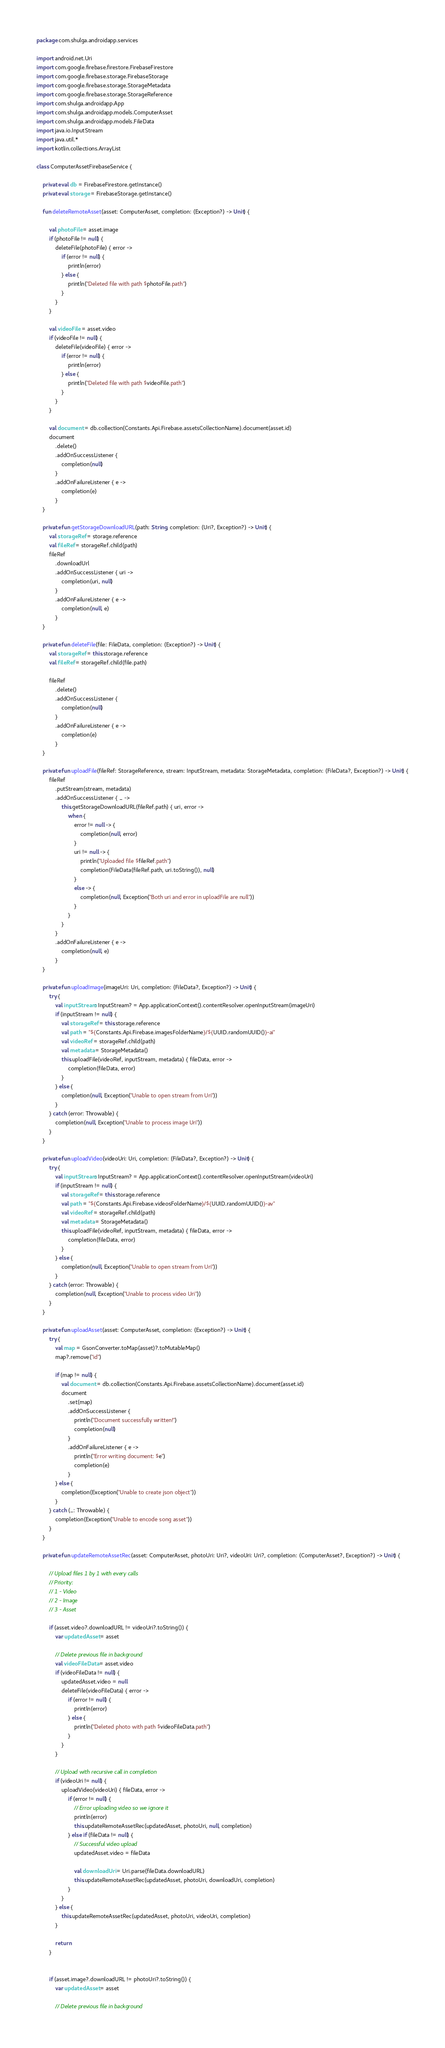Convert code to text. <code><loc_0><loc_0><loc_500><loc_500><_Kotlin_>package com.shulga.androidapp.services

import android.net.Uri
import com.google.firebase.firestore.FirebaseFirestore
import com.google.firebase.storage.FirebaseStorage
import com.google.firebase.storage.StorageMetadata
import com.google.firebase.storage.StorageReference
import com.shulga.androidapp.App
import com.shulga.androidapp.models.ComputerAsset
import com.shulga.androidapp.models.FileData
import java.io.InputStream
import java.util.*
import kotlin.collections.ArrayList

class ComputerAssetFirebaseService {

    private val db = FirebaseFirestore.getInstance()
    private val storage = FirebaseStorage.getInstance()

    fun deleteRemoteAsset(asset: ComputerAsset, completion: (Exception?) -> Unit) {

        val photoFile = asset.image
        if (photoFile != null) {
            deleteFile(photoFile) { error ->
                if (error != null) {
                    println(error)
                } else {
                    println("Deleted file with path $photoFile.path")
                }
            }
        }

        val videoFile = asset.video
        if (videoFile != null) {
            deleteFile(videoFile) { error ->
                if (error != null) {
                    println(error)
                } else {
                    println("Deleted file with path $videoFile.path")
                }
            }
        }

        val document = db.collection(Constants.Api.Firebase.assetsCollectionName).document(asset.id)
        document
            .delete()
            .addOnSuccessListener {
                completion(null)
            }
            .addOnFailureListener { e ->
                completion(e)
            }
    }

    private fun getStorageDownloadURL(path: String, completion: (Uri?, Exception?) -> Unit) {
        val storageRef = storage.reference
        val fileRef = storageRef.child(path)
        fileRef
            .downloadUrl
            .addOnSuccessListener { uri ->
                completion(uri, null)
            }
            .addOnFailureListener { e ->
                completion(null, e)
            }
    }

    private fun deleteFile(file: FileData, completion: (Exception?) -> Unit) {
        val storageRef = this.storage.reference
        val fileRef = storageRef.child(file.path)

        fileRef
            .delete()
            .addOnSuccessListener {
                completion(null)
            }
            .addOnFailureListener { e ->
                completion(e)
            }
    }

    private fun uploadFile(fileRef: StorageReference, stream: InputStream, metadata: StorageMetadata, completion: (FileData?, Exception?) -> Unit) {
        fileRef
            .putStream(stream, metadata)
            .addOnSuccessListener { _ ->
                this.getStorageDownloadURL(fileRef.path) { uri, error ->
                    when {
                        error != null -> {
                            completion(null, error)
                        }
                        uri != null -> {
                            println("Uploaded file $fileRef.path")
                            completion(FileData(fileRef.path, uri.toString()), null)
                        }
                        else -> {
                            completion(null, Exception("Both uri and error in uploadFile are null"))
                        }
                    }
                }
            }
            .addOnFailureListener { e ->
                completion(null, e)
            }
    }

    private fun uploadImage(imageUri: Uri, completion: (FileData?, Exception?) -> Unit) {
        try {
            val inputStream: InputStream? = App.applicationContext().contentResolver.openInputStream(imageUri)
            if (inputStream != null) {
                val storageRef = this.storage.reference
                val path = "${Constants.Api.Firebase.imagesFolderName}/${UUID.randomUUID()}-ai"
                val videoRef = storageRef.child(path)
                val metadata = StorageMetadata()
                this.uploadFile(videoRef, inputStream, metadata) { fileData, error ->
                    completion(fileData, error)
                }
            } else {
                completion(null, Exception("Unable to open stream from Uri"))
            }
        } catch (error: Throwable) {
            completion(null, Exception("Unable to process image Uri"))
        }
    }

    private fun uploadVideo(videoUri: Uri, completion: (FileData?, Exception?) -> Unit) {
        try {
            val inputStream: InputStream? = App.applicationContext().contentResolver.openInputStream(videoUri)
            if (inputStream != null) {
                val storageRef = this.storage.reference
                val path = "${Constants.Api.Firebase.videosFolderName}/${UUID.randomUUID()}-av"
                val videoRef = storageRef.child(path)
                val metadata = StorageMetadata()
                this.uploadFile(videoRef, inputStream, metadata) { fileData, error ->
                    completion(fileData, error)
                }
            } else {
                completion(null, Exception("Unable to open stream from Uri"))
            }
        } catch (error: Throwable) {
            completion(null, Exception("Unable to process video Uri"))
        }
    }

    private fun uploadAsset(asset: ComputerAsset, completion: (Exception?) -> Unit) {
        try {
            val map = GsonConverter.toMap(asset)?.toMutableMap()
            map?.remove("id")

            if (map != null) {
                val document = db.collection(Constants.Api.Firebase.assetsCollectionName).document(asset.id)
                document
                    .set(map)
                    .addOnSuccessListener {
                        println("Document successfully written!")
                        completion(null)
                    }
                    .addOnFailureListener { e ->
                        println("Error writing document: $e")
                        completion(e)
                    }
            } else {
                completion(Exception("Unable to create json object"))
            }
        } catch (_: Throwable) {
            completion(Exception("Unable to encode song asset"))
        }
    }

    private fun updateRemoteAssetRec(asset: ComputerAsset, photoUri: Uri?, videoUri: Uri?, completion: (ComputerAsset?, Exception?) -> Unit) {

        // Upload files 1 by 1 with every calls
        // Priority:
        // 1 - Video
        // 2 - Image
        // 3 - Asset

        if (asset.video?.downloadURL != videoUri?.toString()) {
            var updatedAsset = asset

            // Delete previous file in background
            val videoFileData = asset.video
            if (videoFileData != null) {
                updatedAsset.video = null
                deleteFile(videoFileData) { error ->
                    if (error != null) {
                        println(error)
                    } else {
                        println("Deleted photo with path $videoFileData.path")
                    }
                }
            }

            // Upload with recursive call in completion
            if (videoUri != null) {
                uploadVideo(videoUri) { fileData, error ->
                    if (error != null) {
                        // Error uploading video so we ignore it
                        println(error)
                        this.updateRemoteAssetRec(updatedAsset, photoUri, null, completion)
                    } else if (fileData != null) {
                        // Successful video upload
                        updatedAsset.video = fileData

                        val downloadUri = Uri.parse(fileData.downloadURL)
                        this.updateRemoteAssetRec(updatedAsset, photoUri, downloadUri, completion)
                    }
                }
            } else {
                this.updateRemoteAssetRec(updatedAsset, photoUri, videoUri, completion)
            }

            return
        }


        if (asset.image?.downloadURL != photoUri?.toString()) {
            var updatedAsset = asset

            // Delete previous file in background</code> 